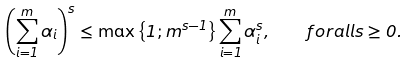<formula> <loc_0><loc_0><loc_500><loc_500>\left ( \sum _ { i = 1 } ^ { m } \alpha _ { i } \right ) ^ { s } \leq \max \left \{ 1 ; m ^ { s - 1 } \right \} \sum _ { i = 1 } ^ { m } \alpha _ { i } ^ { s } , \quad f o r a l l s \geq 0 .</formula> 